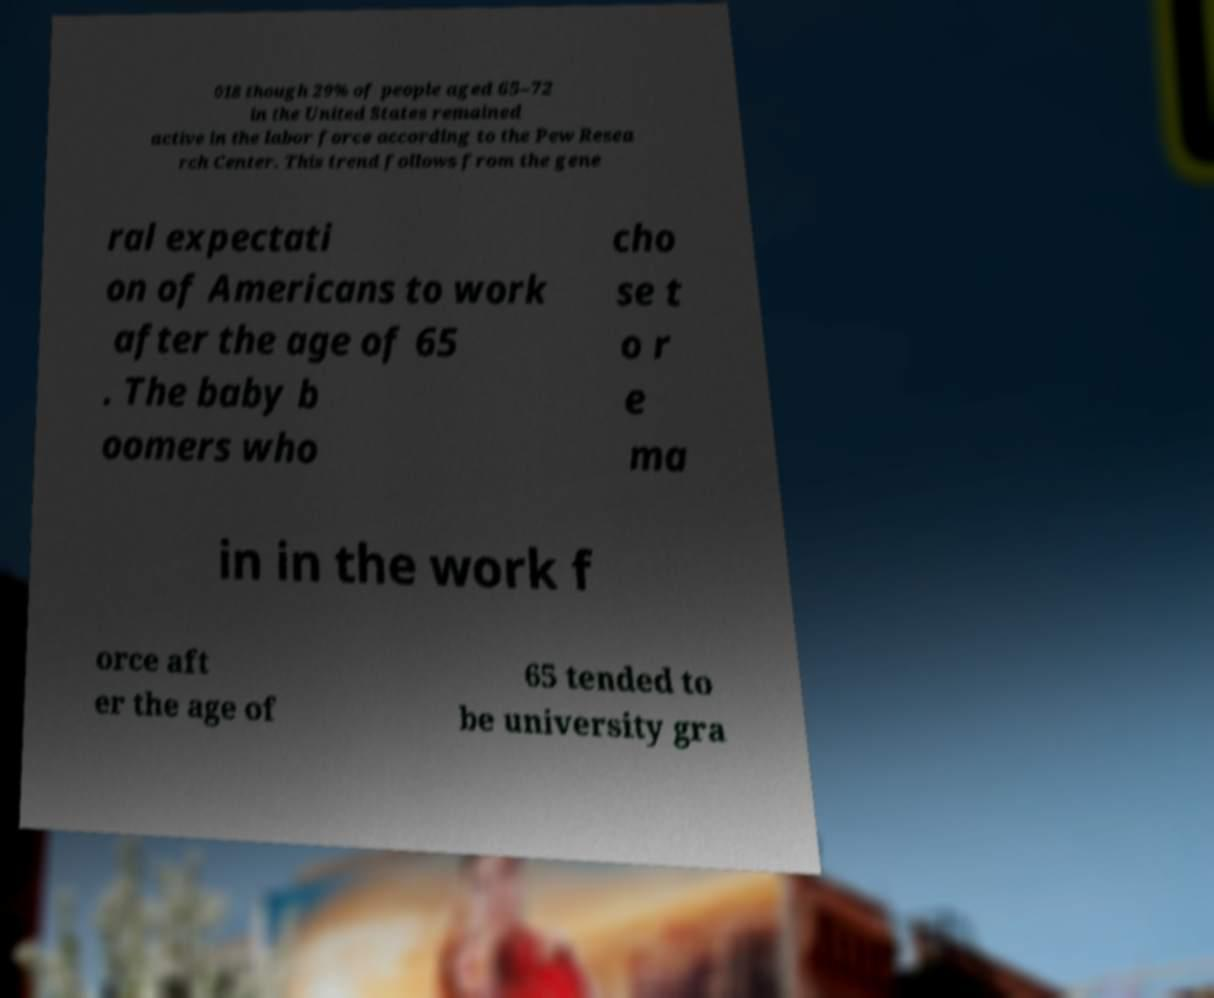What messages or text are displayed in this image? I need them in a readable, typed format. 018 though 29% of people aged 65–72 in the United States remained active in the labor force according to the Pew Resea rch Center. This trend follows from the gene ral expectati on of Americans to work after the age of 65 . The baby b oomers who cho se t o r e ma in in the work f orce aft er the age of 65 tended to be university gra 